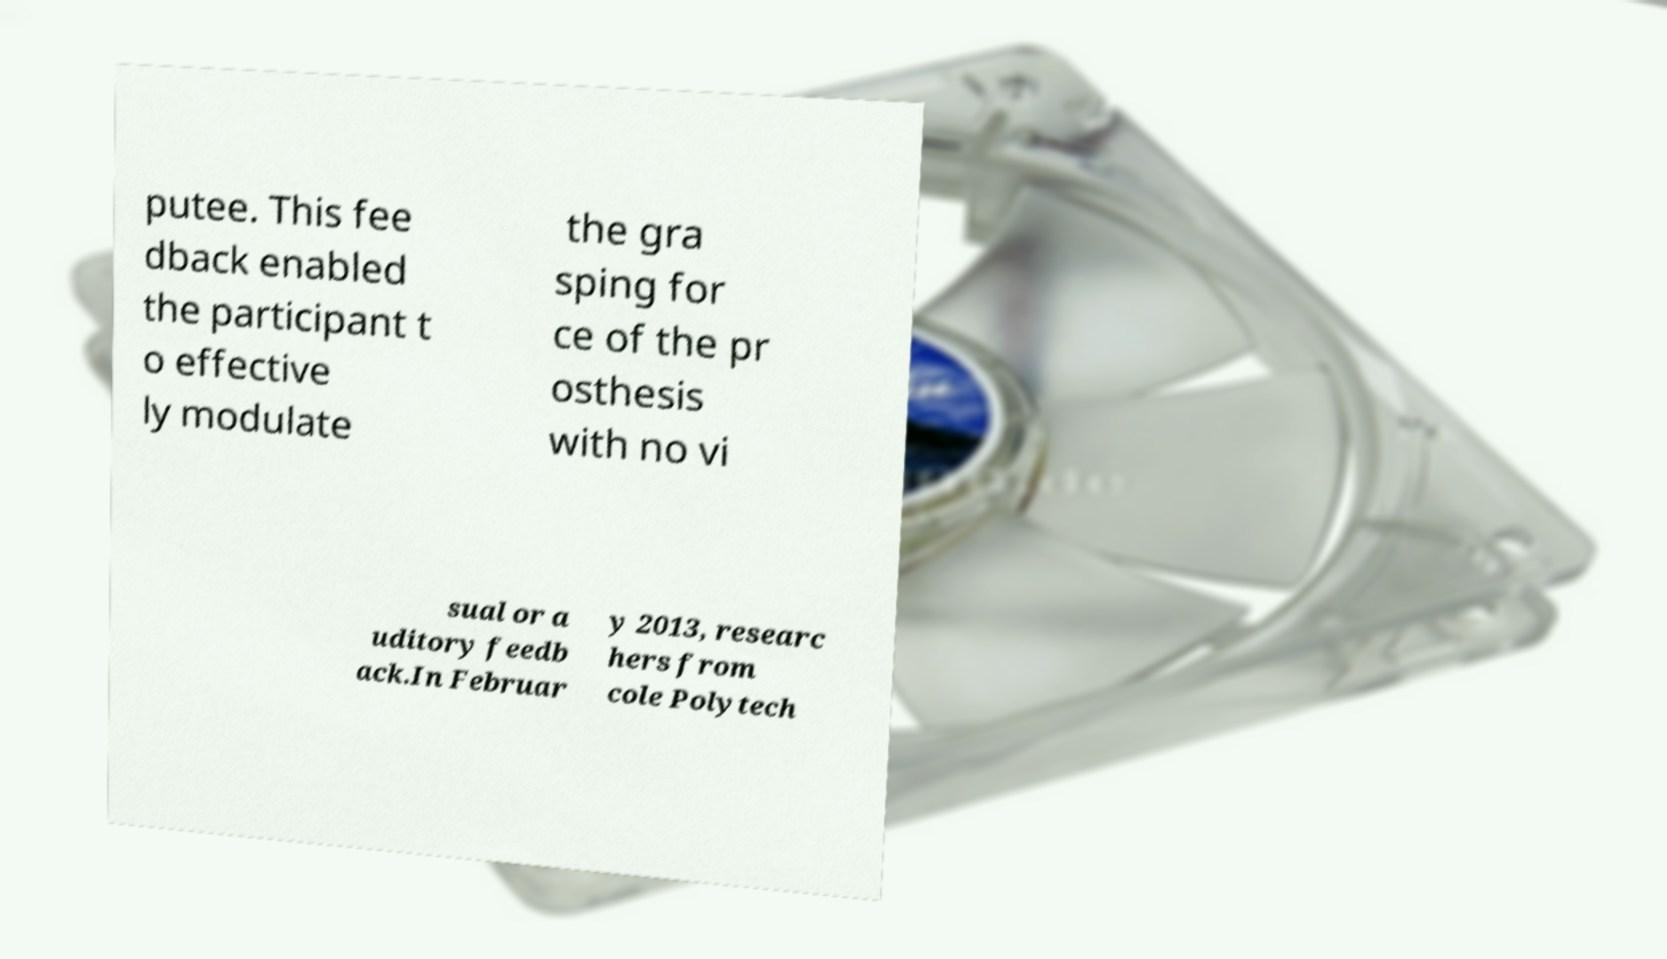For documentation purposes, I need the text within this image transcribed. Could you provide that? putee. This fee dback enabled the participant t o effective ly modulate the gra sping for ce of the pr osthesis with no vi sual or a uditory feedb ack.In Februar y 2013, researc hers from cole Polytech 